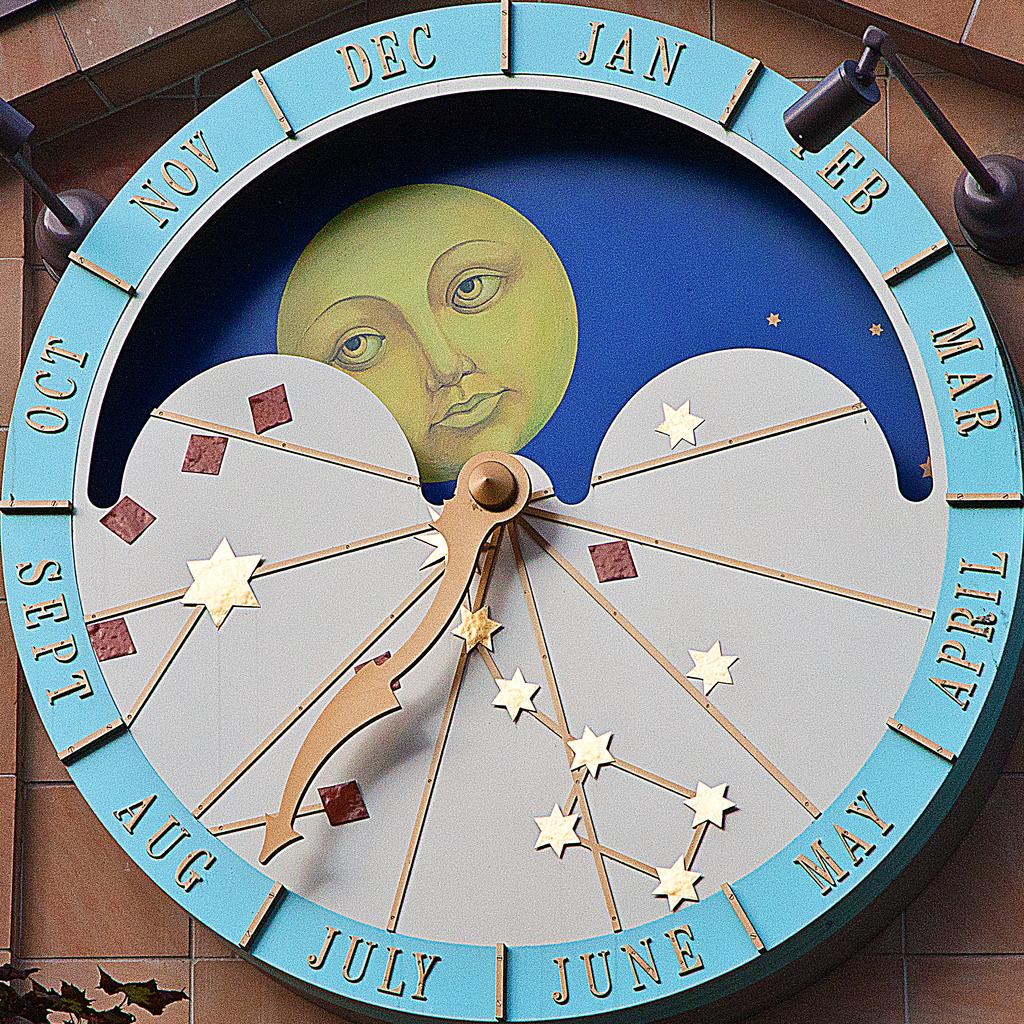<image>
Describe the image concisely. A Calendar clock with stars and the moon on it point towards August 